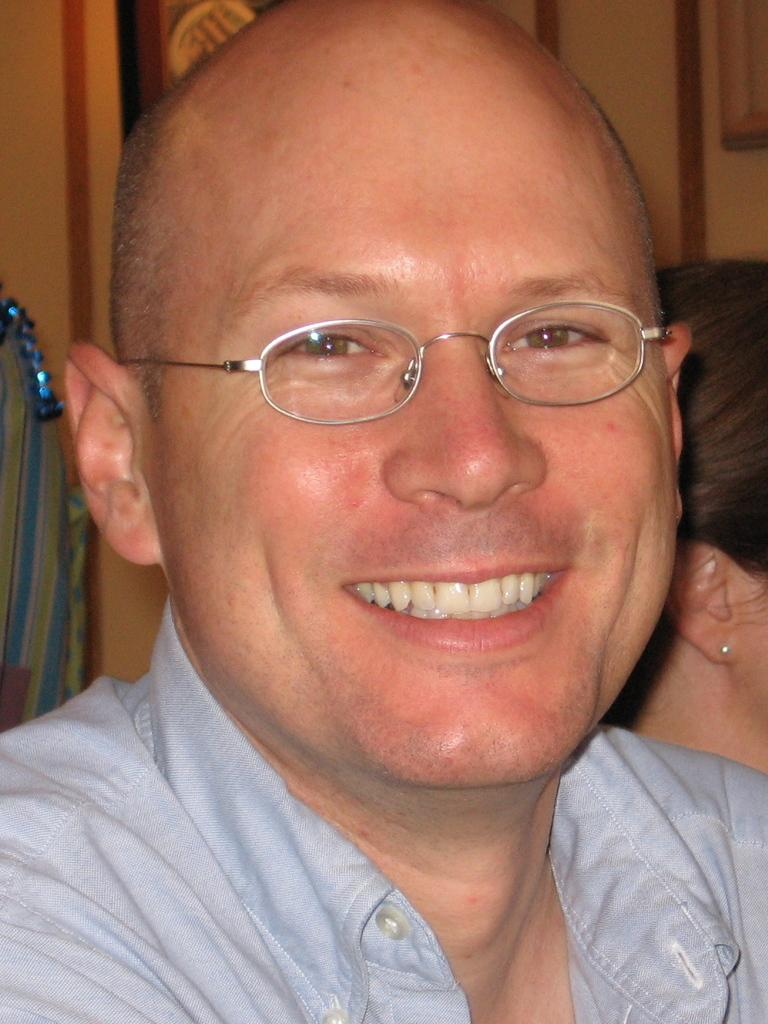Who is present in the image? There is a person in the image. What is the person doing in the image? The person is smiling. What accessory is the person wearing in the image? The person is wearing spectacles. Can you describe the background of the image? There is another person and objects visible in the background of the image. How many bikes are visible in the image? There are no bikes present in the image. What type of parent is visible in the image? There is no parent visible in the image. 